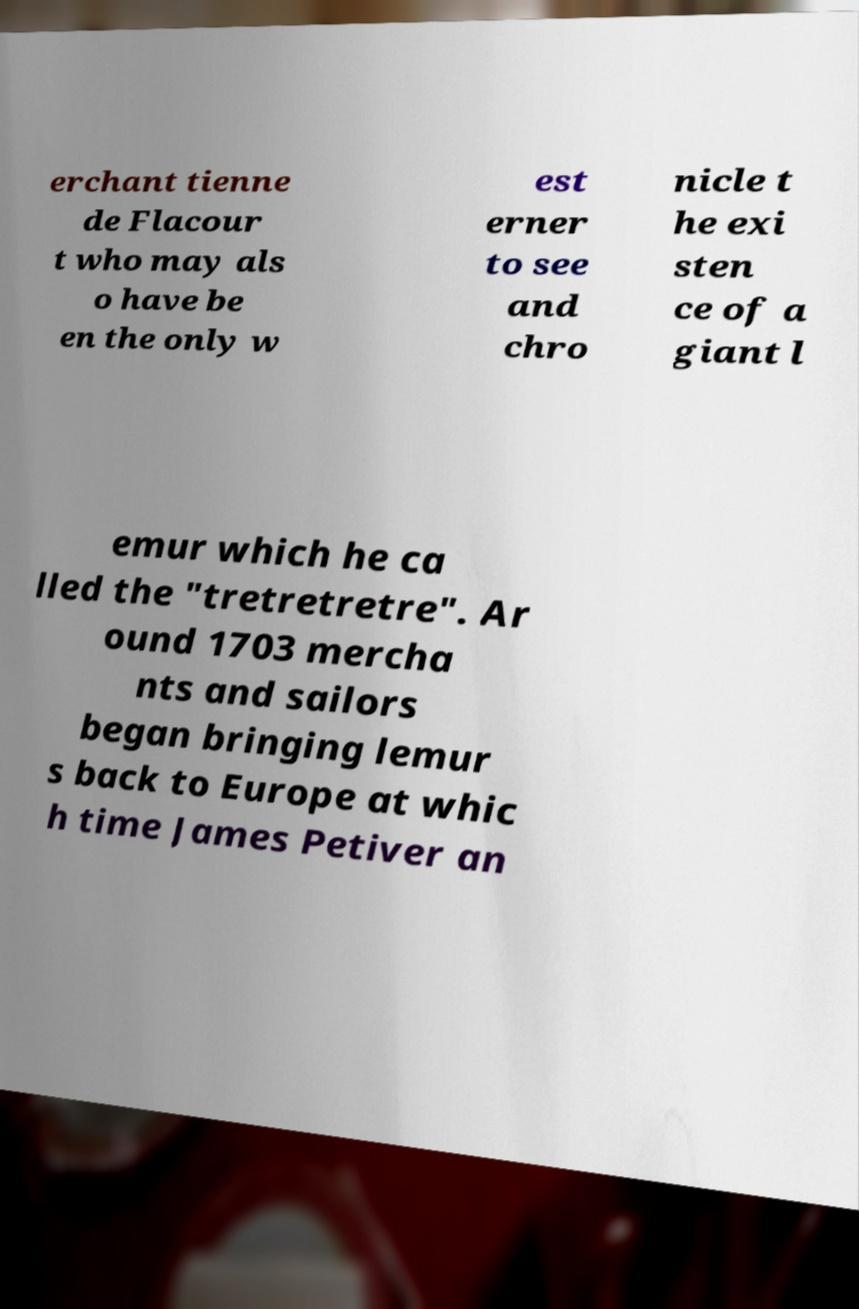Could you assist in decoding the text presented in this image and type it out clearly? erchant tienne de Flacour t who may als o have be en the only w est erner to see and chro nicle t he exi sten ce of a giant l emur which he ca lled the "tretretretre". Ar ound 1703 mercha nts and sailors began bringing lemur s back to Europe at whic h time James Petiver an 